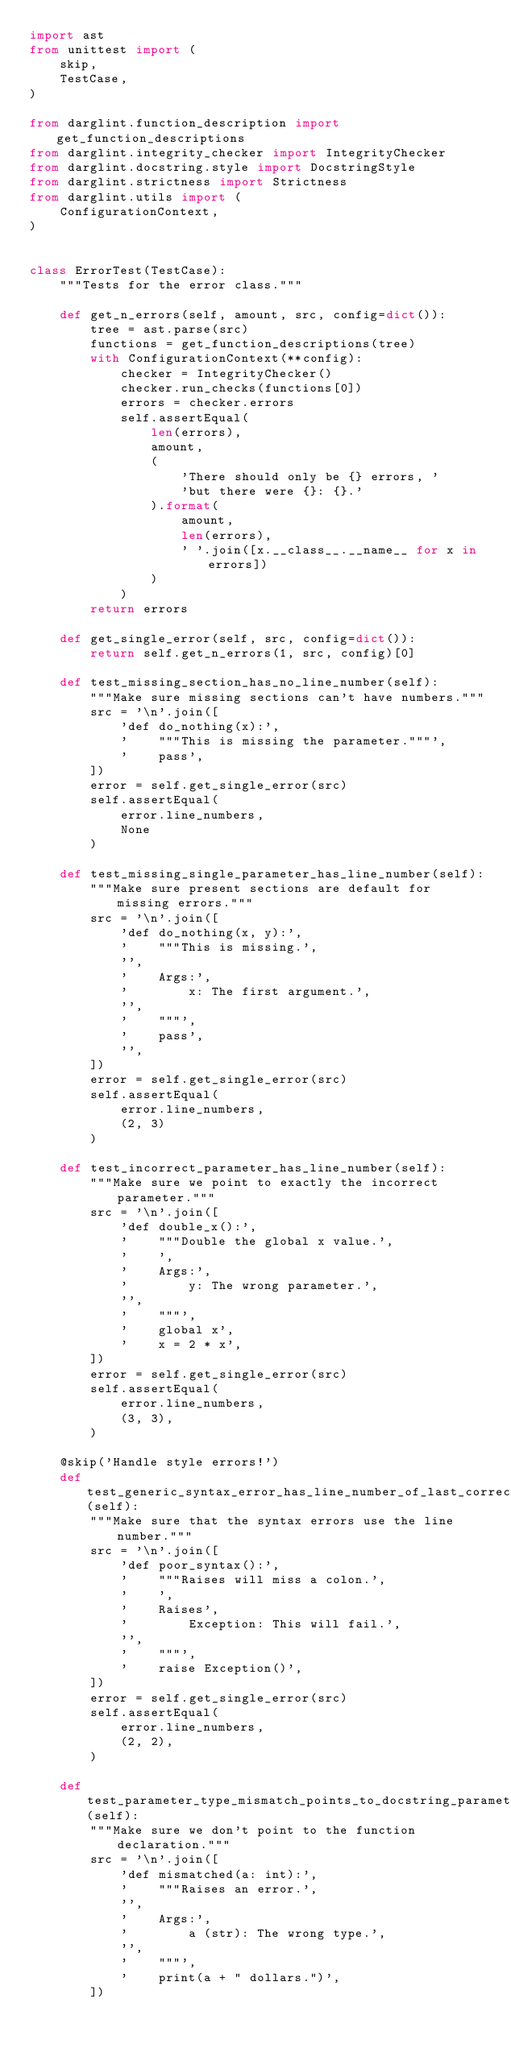<code> <loc_0><loc_0><loc_500><loc_500><_Python_>import ast
from unittest import (
    skip,
    TestCase,
)

from darglint.function_description import get_function_descriptions
from darglint.integrity_checker import IntegrityChecker
from darglint.docstring.style import DocstringStyle
from darglint.strictness import Strictness
from darglint.utils import (
    ConfigurationContext,
)


class ErrorTest(TestCase):
    """Tests for the error class."""

    def get_n_errors(self, amount, src, config=dict()):
        tree = ast.parse(src)
        functions = get_function_descriptions(tree)
        with ConfigurationContext(**config):
            checker = IntegrityChecker()
            checker.run_checks(functions[0])
            errors = checker.errors
            self.assertEqual(
                len(errors),
                amount,
                (
                    'There should only be {} errors, '
                    'but there were {}: {}.'
                ).format(
                    amount,
                    len(errors),
                    ' '.join([x.__class__.__name__ for x in errors])
                )
            )
        return errors

    def get_single_error(self, src, config=dict()):
        return self.get_n_errors(1, src, config)[0]

    def test_missing_section_has_no_line_number(self):
        """Make sure missing sections can't have numbers."""
        src = '\n'.join([
            'def do_nothing(x):',
            '    """This is missing the parameter."""',
            '    pass',
        ])
        error = self.get_single_error(src)
        self.assertEqual(
            error.line_numbers,
            None
        )

    def test_missing_single_parameter_has_line_number(self):
        """Make sure present sections are default for missing errors."""
        src = '\n'.join([
            'def do_nothing(x, y):',
            '    """This is missing.',
            '',
            '    Args:',
            '        x: The first argument.',
            '',
            '    """',
            '    pass',
            '',
        ])
        error = self.get_single_error(src)
        self.assertEqual(
            error.line_numbers,
            (2, 3)
        )

    def test_incorrect_parameter_has_line_number(self):
        """Make sure we point to exactly the incorrect parameter."""
        src = '\n'.join([
            'def double_x():',
            '    """Double the global x value.',
            '    ',
            '    Args:',
            '        y: The wrong parameter.',
            '',
            '    """',
            '    global x',
            '    x = 2 * x',
        ])
        error = self.get_single_error(src)
        self.assertEqual(
            error.line_numbers,
            (3, 3),
        )

    @skip('Handle style errors!')
    def test_generic_syntax_error_has_line_number_of_last_correct(self):
        """Make sure that the syntax errors use the line number."""
        src = '\n'.join([
            'def poor_syntax():',
            '    """Raises will miss a colon.',
            '    ',
            '    Raises',
            '        Exception: This will fail.',
            '',
            '    """',
            '    raise Exception()',
        ])
        error = self.get_single_error(src)
        self.assertEqual(
            error.line_numbers,
            (2, 2),
        )

    def test_parameter_type_mismatch_points_to_docstring_parameter(self):
        """Make sure we don't point to the function declaration."""
        src = '\n'.join([
            'def mismatched(a: int):',
            '    """Raises an error.',
            '',
            '    Args:',
            '        a (str): The wrong type.',
            '',
            '    """',
            '    print(a + " dollars.")',
        ])</code> 